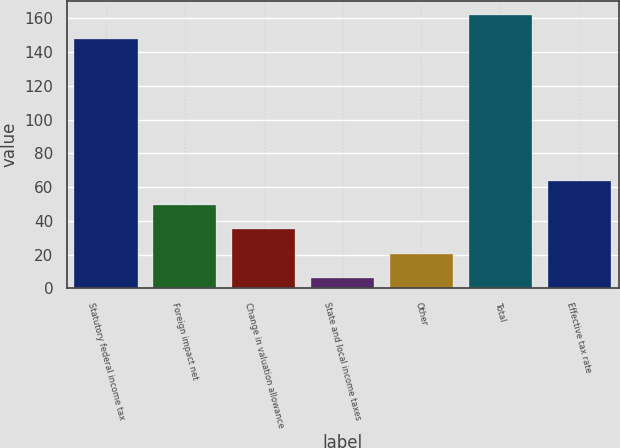<chart> <loc_0><loc_0><loc_500><loc_500><bar_chart><fcel>Statutory federal income tax<fcel>Foreign impact net<fcel>Change in valuation allowance<fcel>State and local income taxes<fcel>Other<fcel>Total<fcel>Effective tax rate<nl><fcel>147.8<fcel>49.15<fcel>34.9<fcel>6.4<fcel>20.65<fcel>162.05<fcel>63.4<nl></chart> 